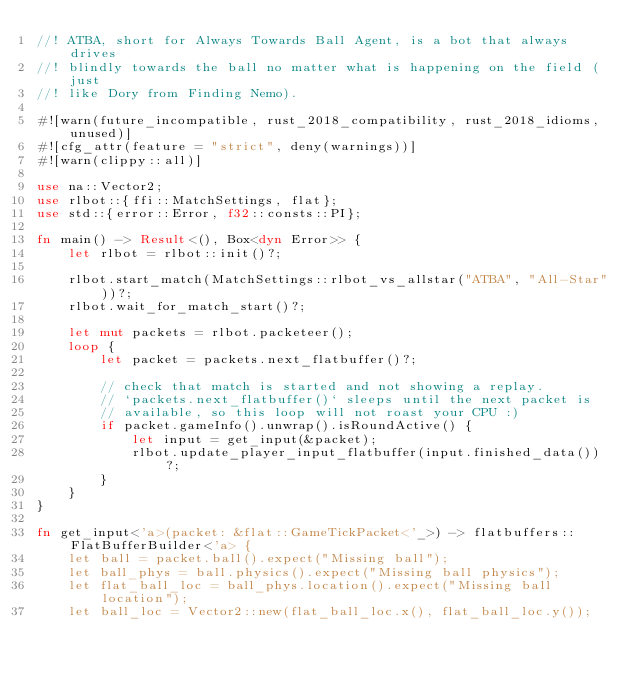Convert code to text. <code><loc_0><loc_0><loc_500><loc_500><_Rust_>//! ATBA, short for Always Towards Ball Agent, is a bot that always drives
//! blindly towards the ball no matter what is happening on the field (just
//! like Dory from Finding Nemo).

#![warn(future_incompatible, rust_2018_compatibility, rust_2018_idioms, unused)]
#![cfg_attr(feature = "strict", deny(warnings))]
#![warn(clippy::all)]

use na::Vector2;
use rlbot::{ffi::MatchSettings, flat};
use std::{error::Error, f32::consts::PI};

fn main() -> Result<(), Box<dyn Error>> {
    let rlbot = rlbot::init()?;

    rlbot.start_match(MatchSettings::rlbot_vs_allstar("ATBA", "All-Star"))?;
    rlbot.wait_for_match_start()?;

    let mut packets = rlbot.packeteer();
    loop {
        let packet = packets.next_flatbuffer()?;

        // check that match is started and not showing a replay.
        // `packets.next_flatbuffer()` sleeps until the next packet is
        // available, so this loop will not roast your CPU :)
        if packet.gameInfo().unwrap().isRoundActive() {
            let input = get_input(&packet);
            rlbot.update_player_input_flatbuffer(input.finished_data())?;
        }
    }
}

fn get_input<'a>(packet: &flat::GameTickPacket<'_>) -> flatbuffers::FlatBufferBuilder<'a> {
    let ball = packet.ball().expect("Missing ball");
    let ball_phys = ball.physics().expect("Missing ball physics");
    let flat_ball_loc = ball_phys.location().expect("Missing ball location");
    let ball_loc = Vector2::new(flat_ball_loc.x(), flat_ball_loc.y());
</code> 